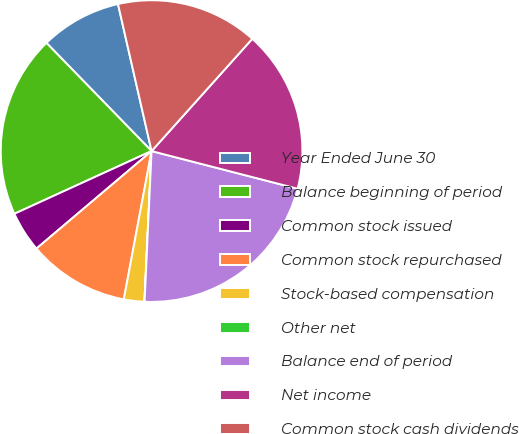Convert chart. <chart><loc_0><loc_0><loc_500><loc_500><pie_chart><fcel>Year Ended June 30<fcel>Balance beginning of period<fcel>Common stock issued<fcel>Common stock repurchased<fcel>Stock-based compensation<fcel>Other net<fcel>Balance end of period<fcel>Net income<fcel>Common stock cash dividends<nl><fcel>8.7%<fcel>19.55%<fcel>4.36%<fcel>10.87%<fcel>2.19%<fcel>0.02%<fcel>21.72%<fcel>17.38%<fcel>15.21%<nl></chart> 